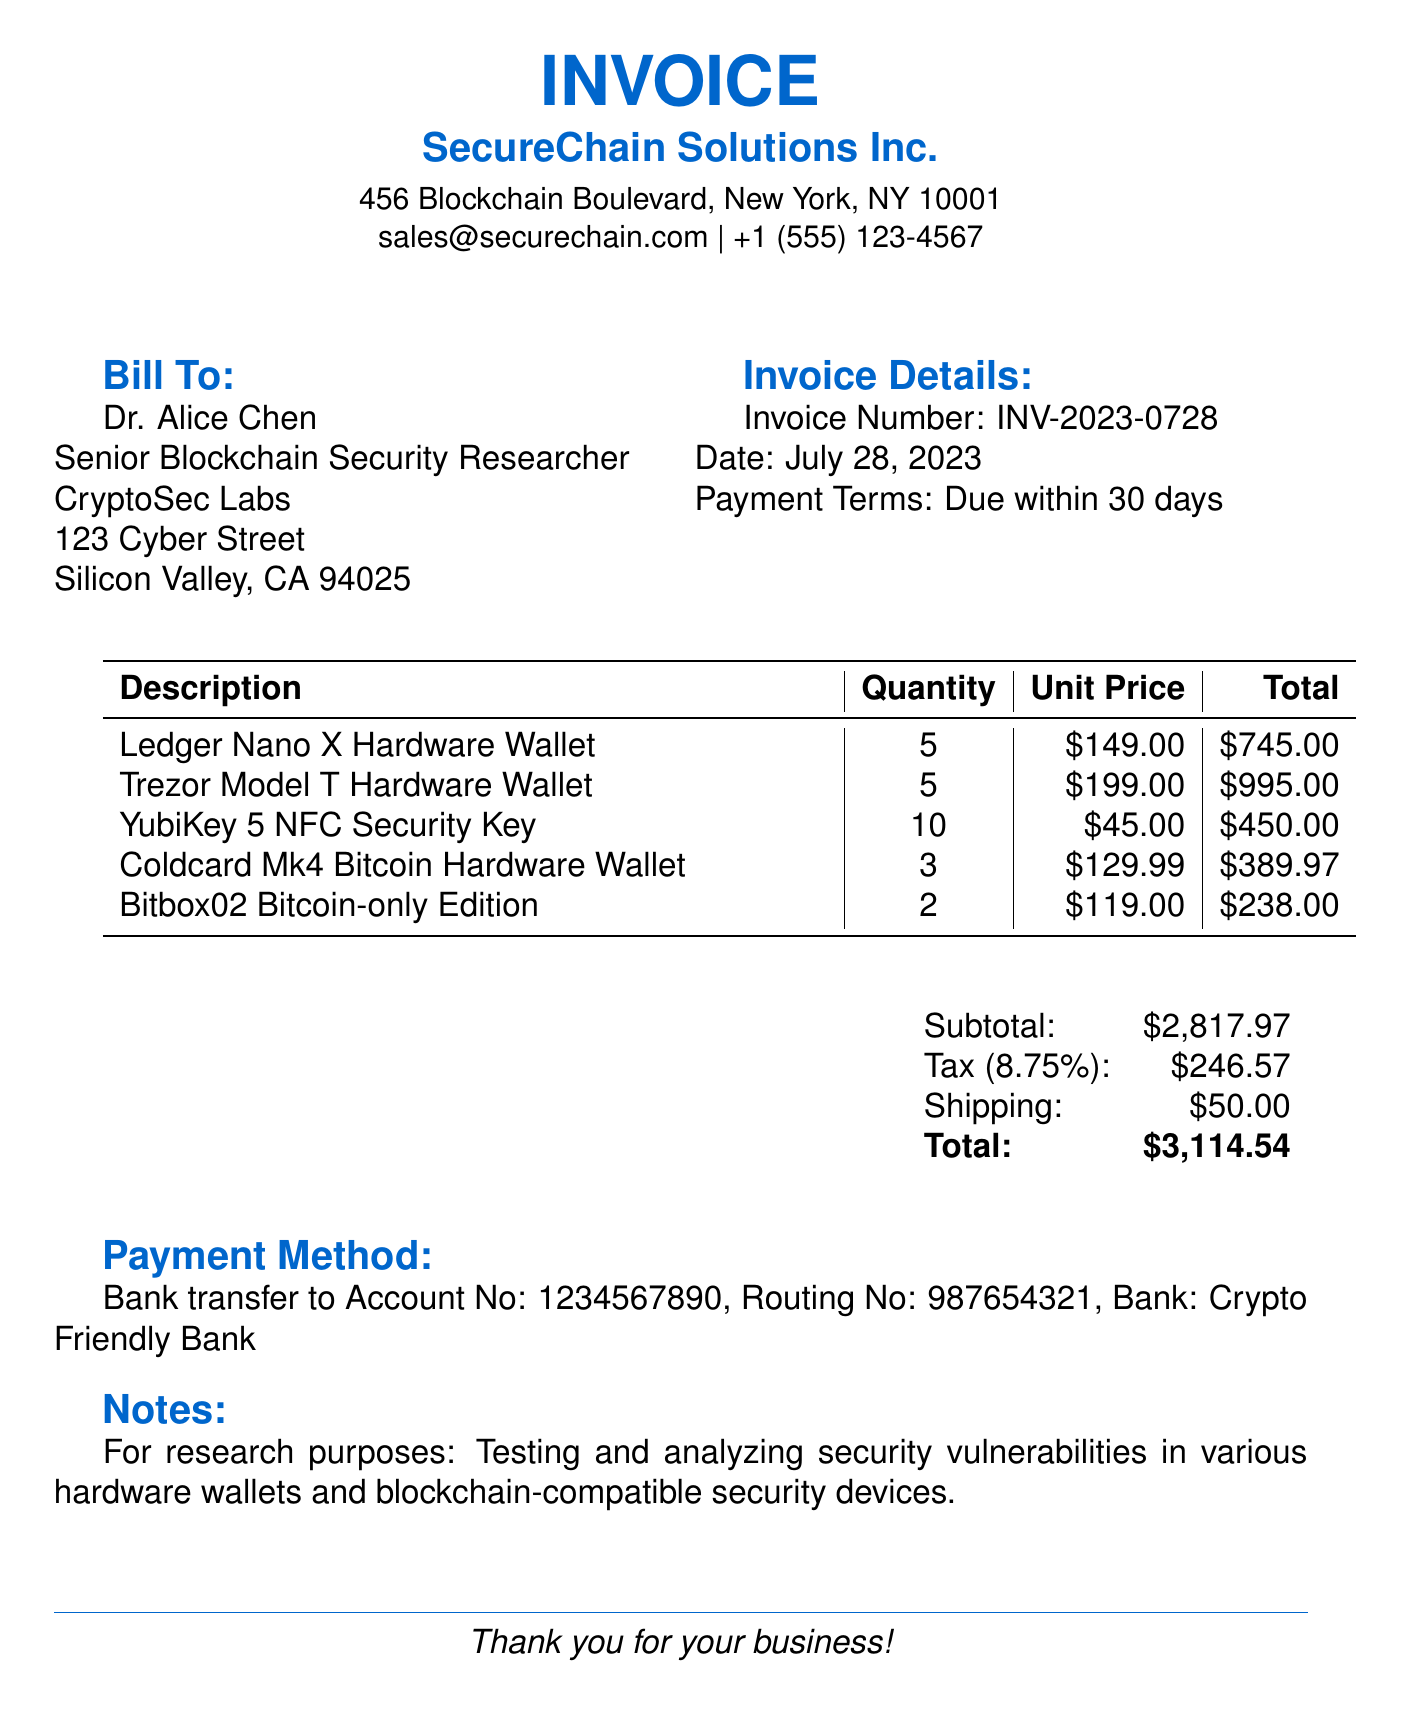What is the invoice number? The invoice number is specified in the document as INV-2023-0728.
Answer: INV-2023-0728 Who is the bill addressed to? The bill is addressed to Dr. Alice Chen, Senior Blockchain Security Researcher at CryptoSec Labs.
Answer: Dr. Alice Chen What is the total amount due? The total amount due is indicated at the bottom of the invoice as $3,114.54.
Answer: $3,114.54 How many Trezor Model T Hardware Wallets were purchased? The quantity of Trezor Model T Hardware Wallets is listed as 5 in the invoice.
Answer: 5 What is the shipping cost? The shipping cost is shown as $50.00 in the invoice.
Answer: $50.00 What is the payment term specified in the invoice? The payment term is noted as due within 30 days.
Answer: Due within 30 days What is the subtotal before tax and shipping? The subtotal is calculated as the sum of all the item totals before tax and shipping, which is $2,817.97.
Answer: $2,817.97 What is the purpose of this purchase according to the notes? The purpose is noted as testing and analyzing security vulnerabilities in various hardware wallets and blockchain-compatible security devices.
Answer: Testing and analyzing security vulnerabilities in various hardware wallets and blockchain-compatible security devices What type of document is this? This document is an invoice.
Answer: Invoice 